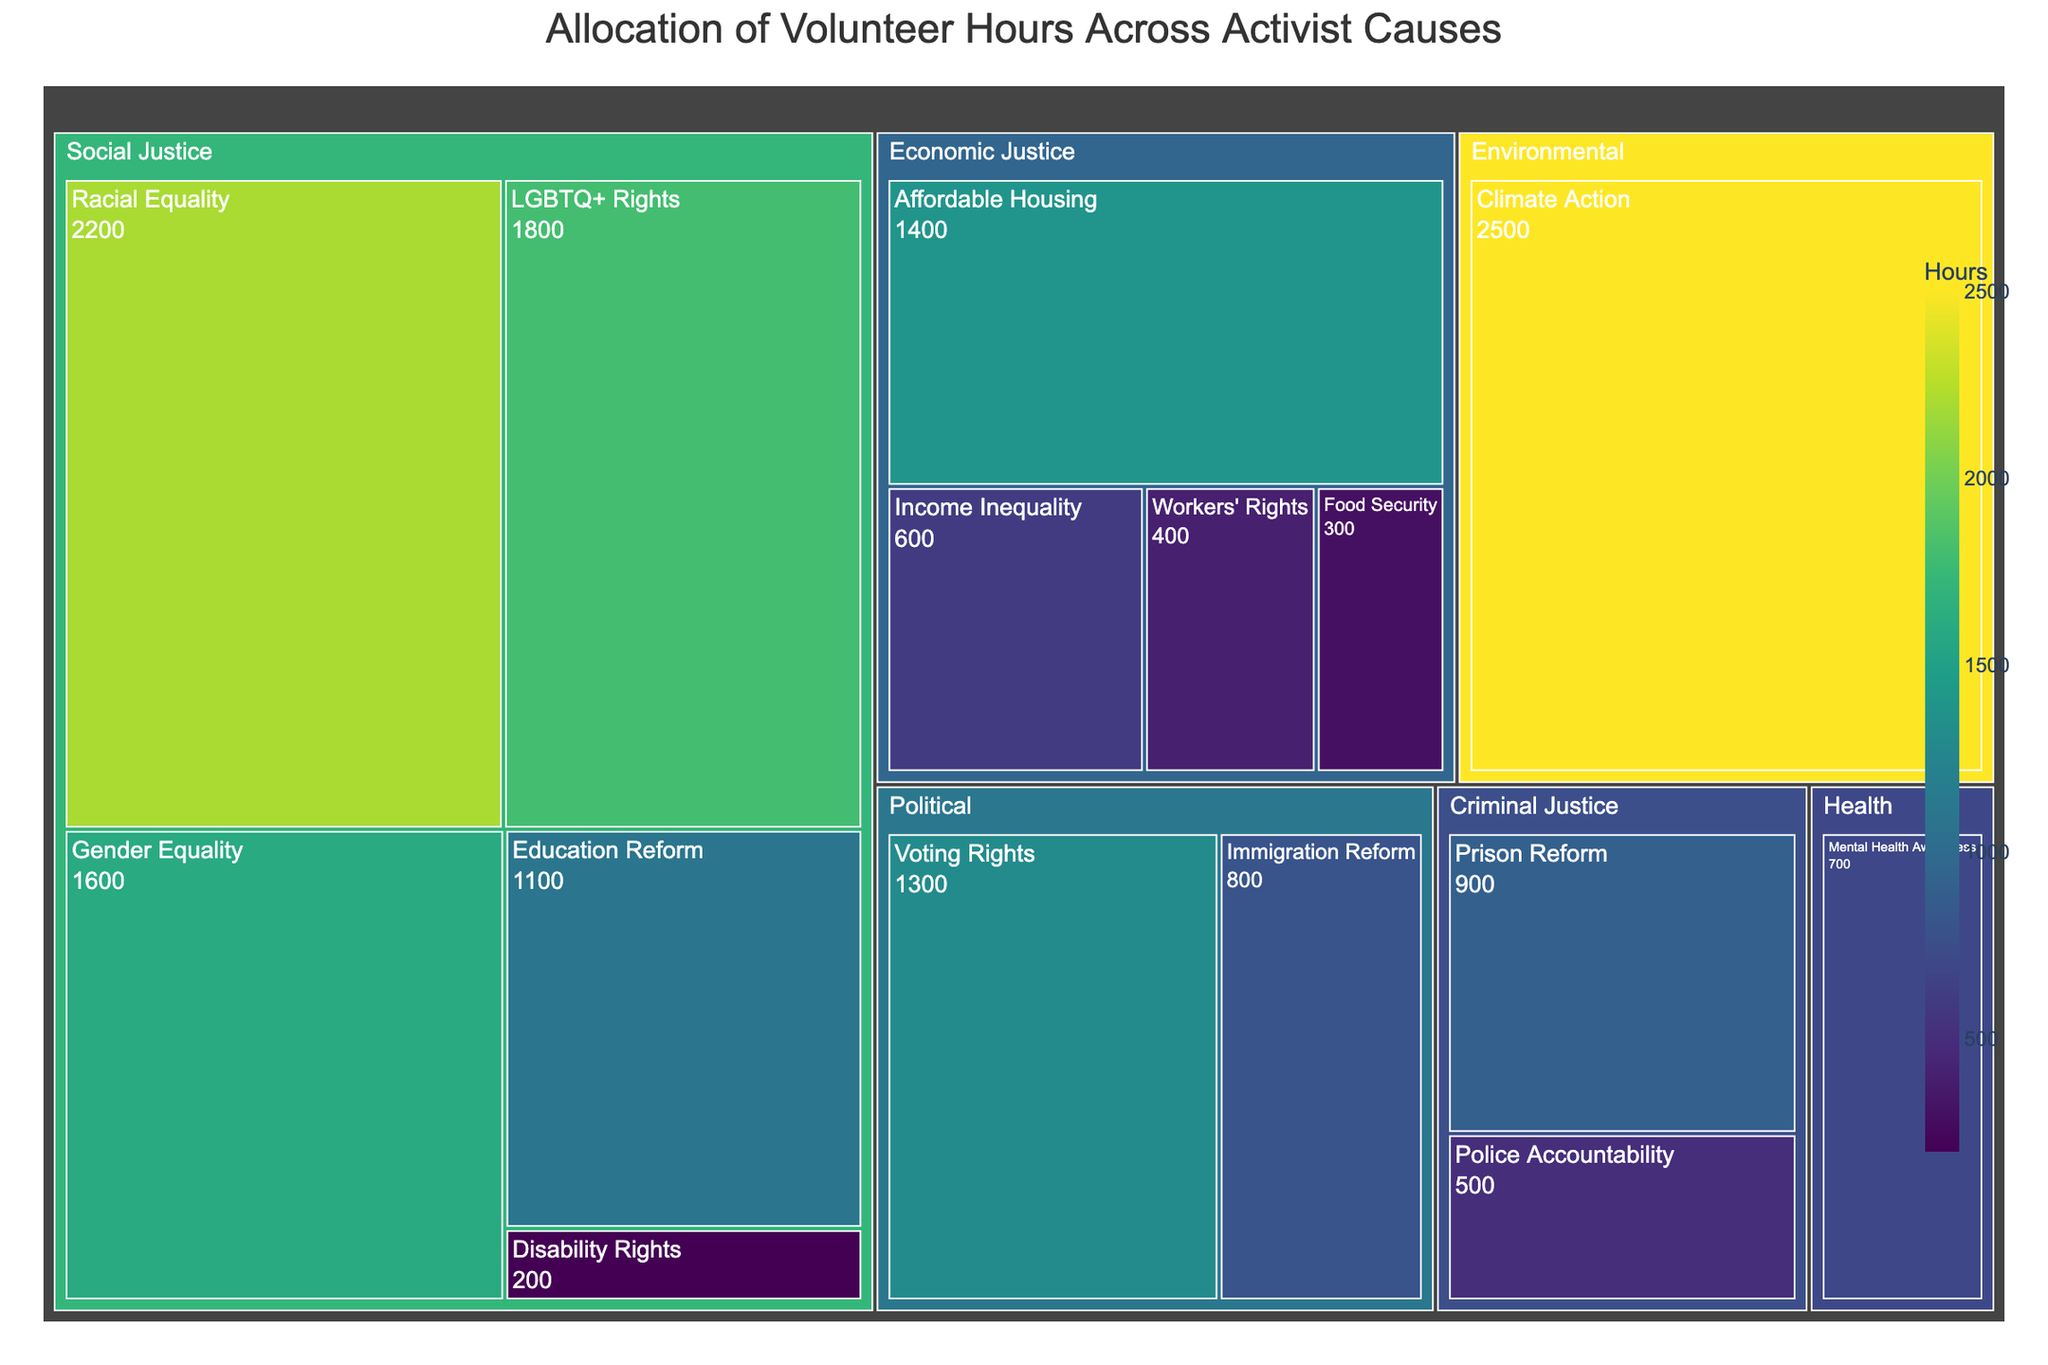What is the title of the figure? The title is usually found at the top of the figure and indicates what the plot is about. In this treemap, the title provides an overview of the data being visualized.
Answer: Allocation of Volunteer Hours Across Activist Causes Which cause in the Social Justice category has the highest allocation of volunteer hours? To find this, locate the Social Justice category block and identify the cause within it that has the largest area. This cause will have the highest number of hours.
Answer: Racial Equality How many volunteer hours are allocated to Environmental causes? Find the Environmental category block and sum the hours allocated. In this case, there is only one cause within the Environmental category.
Answer: 2500 Which category has the smallest total allocation of volunteer hours, and what is the amount? Compare the total areas of all categories. The smallest area corresponds to the category with the least volunteer hours.
Answer: Health, 700 What's the combined total of volunteer hours for Economic Justice causes? Identify all causes under the Economic Justice category and sum their hours. They include Affordable Housing (1400), Income Inequality (600), Workers' Rights (400), and Food Security (300). 1400 + 600 + 400 + 300 = 2700
Answer: 2700 Is Voting Rights allocated more or less volunteer hours than Climate Action? Compare the areas for Voting Rights and Climate Action. The larger area corresponds to the cause with more volunteer hours.
Answer: Less How many categories have more than one cause listed under them? Count the number of categories that contain multiple causes by observing the subdivisions in each category block.
Answer: Three (Social Justice, Economic Justice, and Criminal Justice) What is the difference in volunteer hours between the cause with the highest and the cause with the lowest allocation? Identify the cause with the highest hours (Climate Action: 2500) and the cause with the lowest hours (Disability Rights: 200), then subtract the smaller from the larger. 2500 - 200 = 2300
Answer: 2300 Which cause has the smallest allocation of volunteer hours, and in which category is it? Locate the smallest block in the entire treemap and note the associated cause and category.
Answer: Disability Rights, Social Justice What percentage of total volunteer hours is allocated to Political causes? First, sum the hours for all Political causes (Voting Rights: 1300, Immigration Reform: 800). Then, sum the total hours for all causes across the treemap. Finally, divide the hours for Political causes by the total hours and multiply by 100 to get the percentage. (1300 + 800) / 16000 * 100 = 13.13%
Answer: 13.13% 